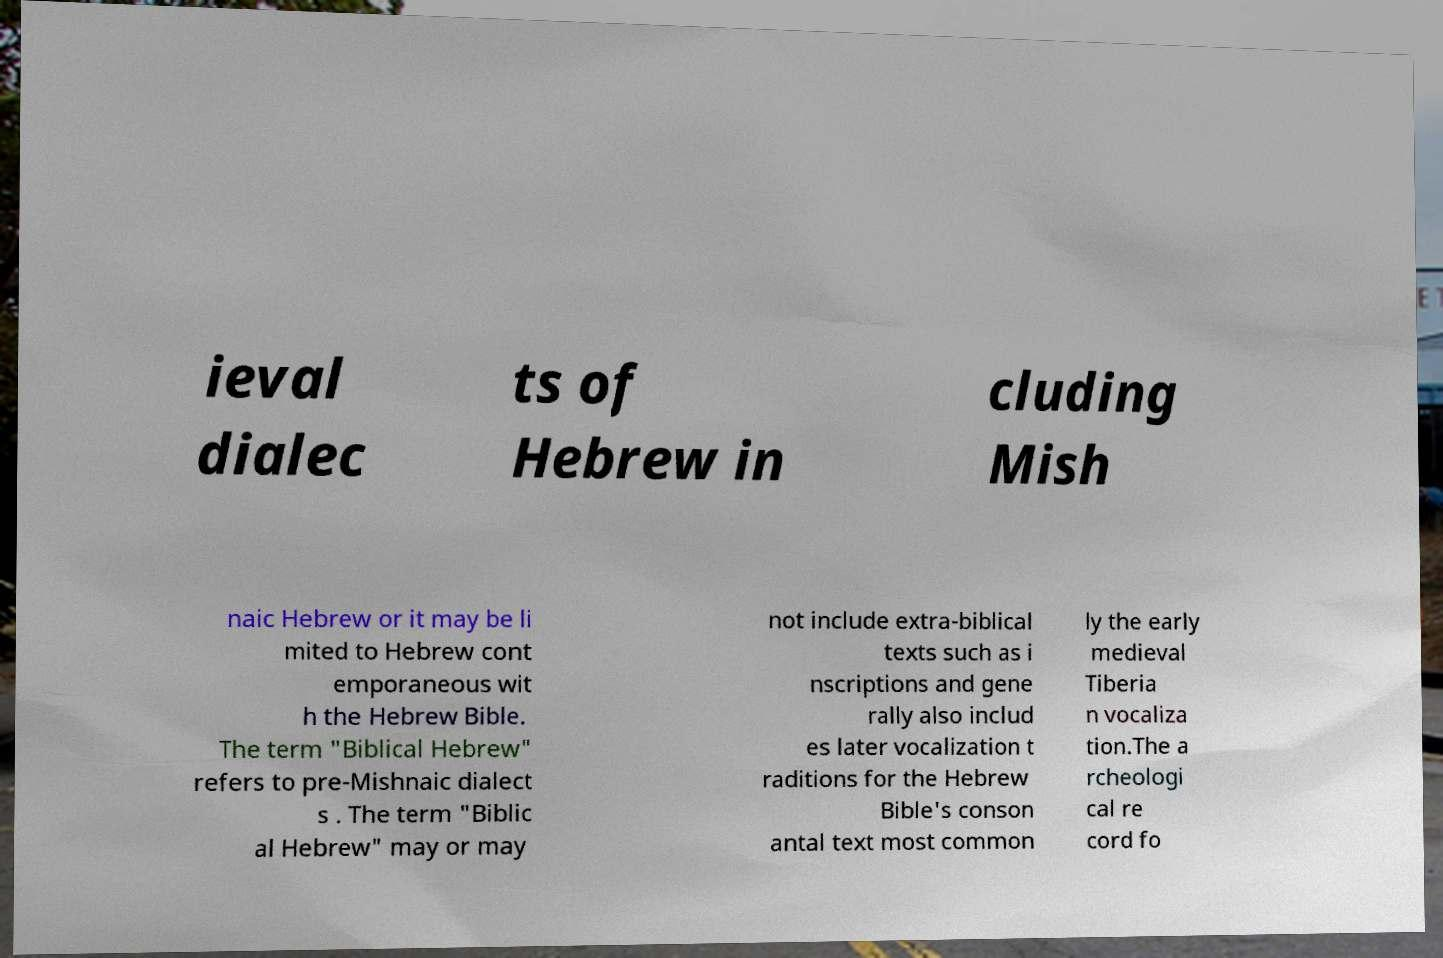Could you assist in decoding the text presented in this image and type it out clearly? ieval dialec ts of Hebrew in cluding Mish naic Hebrew or it may be li mited to Hebrew cont emporaneous wit h the Hebrew Bible. The term "Biblical Hebrew" refers to pre-Mishnaic dialect s . The term "Biblic al Hebrew" may or may not include extra-biblical texts such as i nscriptions and gene rally also includ es later vocalization t raditions for the Hebrew Bible's conson antal text most common ly the early medieval Tiberia n vocaliza tion.The a rcheologi cal re cord fo 